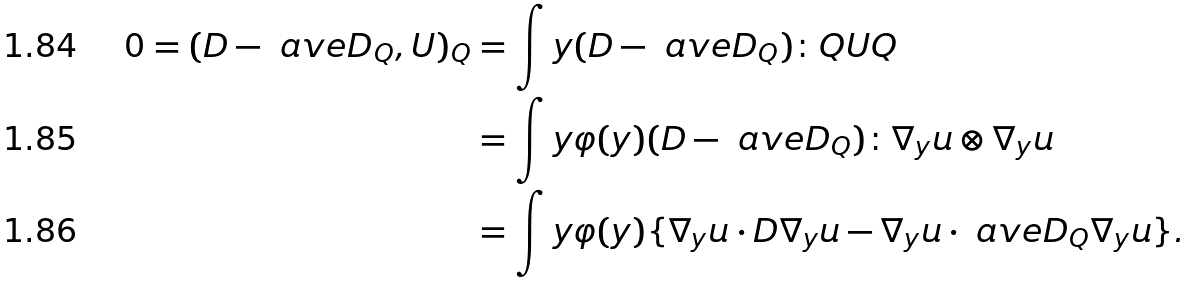<formula> <loc_0><loc_0><loc_500><loc_500>0 = ( D - \ a v e { D } _ { Q } , U ) _ { Q } & = \int y { ( D - \ a v e { D } _ { Q } ) \colon Q U Q } \\ & = \int y { \varphi ( y ) ( D - \ a v e { D } _ { Q } ) \colon \nabla _ { y } u \otimes \nabla _ { y } u } \\ & = \int y { \varphi ( y ) \{ \nabla _ { y } u \cdot D \nabla _ { y } u - \nabla _ { y } u \cdot \ a v e { D } _ { Q } \nabla _ { y } u \} } .</formula> 